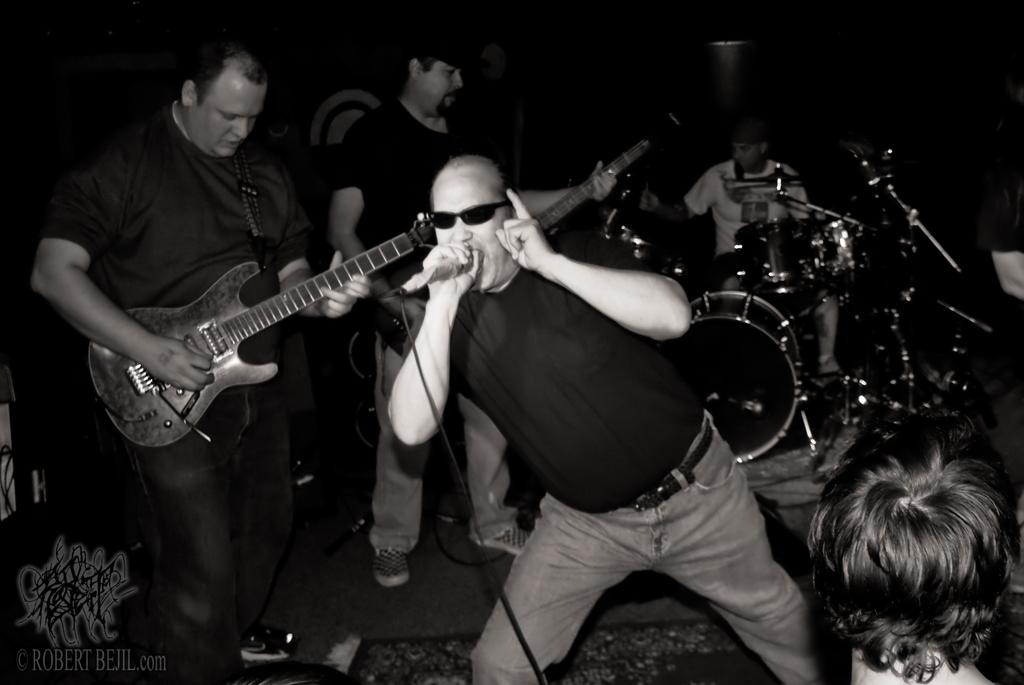How many people are performing on the musical stage in the image? There are four persons in the image. What instruments are being played by the performers? One person is playing a guitar, and another is playing a snare drum. Are any of the performers singing? Yes, one or more persons are singing on a microphone. Can you see a pail being used by any of the performers in the image? There is no pail present in the image. What type of approval rating does the performance have in the image? The image does not show any indication of an approval rating for the performance. 